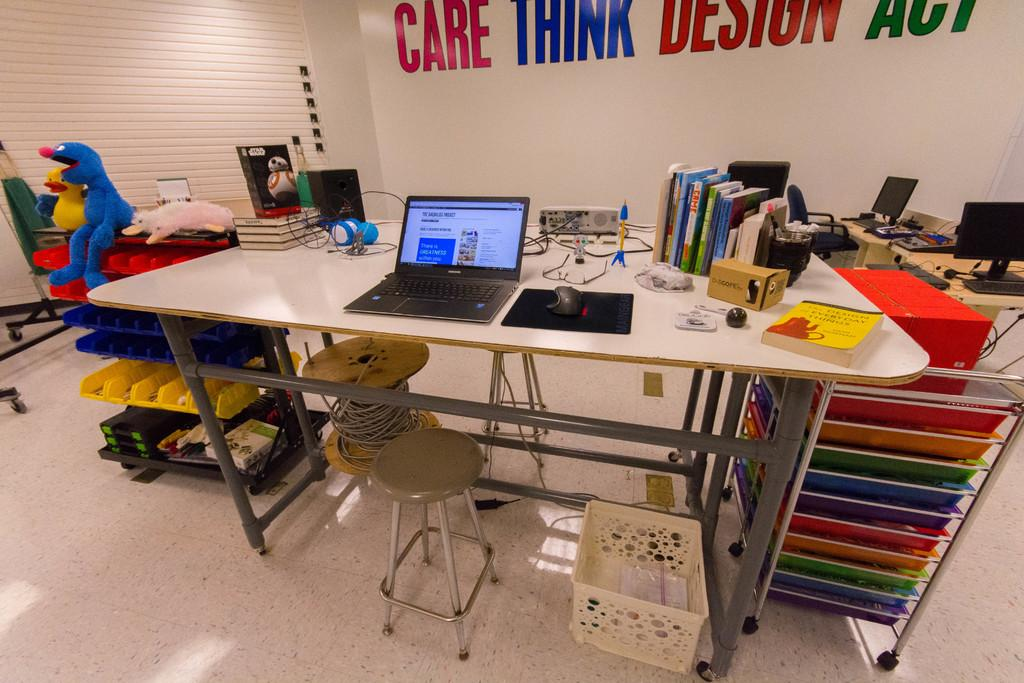What piece of furniture is present in the image? There is a table in the image. What electronic device is on the table? The table has a laptop on it. What accessory is used for controlling the laptop? There is a mouse on the table. What type of items can be seen on the table besides the laptop and mouse? There are books and a projector on the table. What additional object is present near the table? There is a toy beside the table. What type of furniture is in the right corner of the image? There are desktops in the right corner of the image. What sound can be heard coming from the toy in the image? There is no sound coming from the toy in the image, as it is not specified whether the toy is functional or not. 